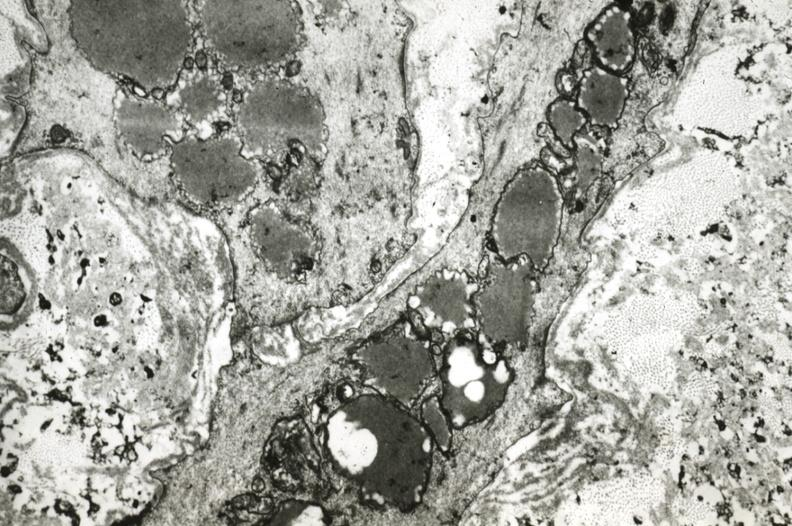s slide present?
Answer the question using a single word or phrase. No 